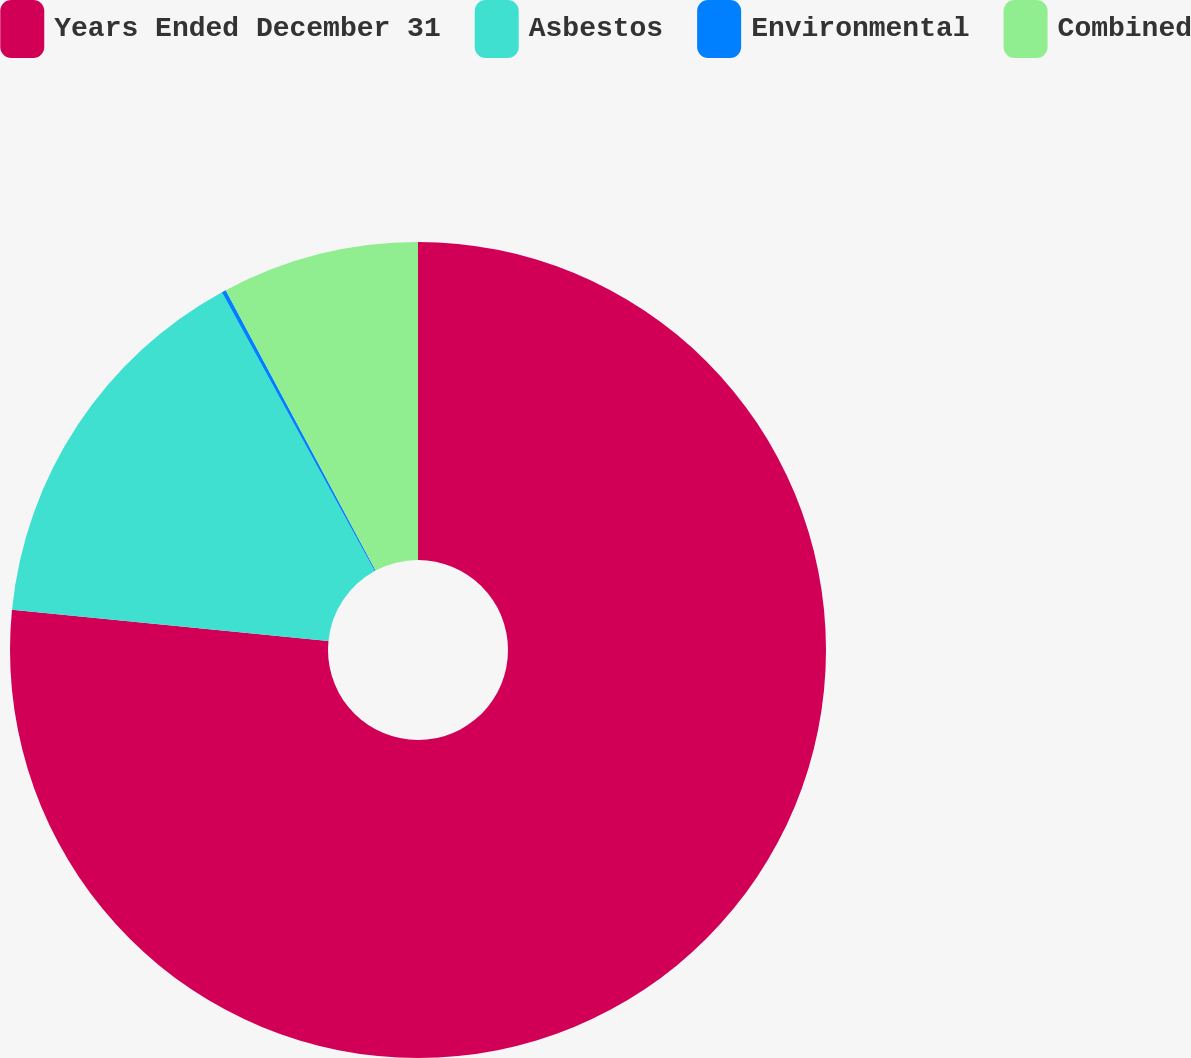<chart> <loc_0><loc_0><loc_500><loc_500><pie_chart><fcel>Years Ended December 31<fcel>Asbestos<fcel>Environmental<fcel>Combined<nl><fcel>76.58%<fcel>15.45%<fcel>0.17%<fcel>7.81%<nl></chart> 